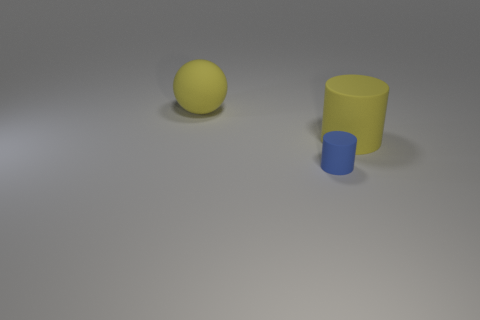What number of things are either big yellow objects that are in front of the big rubber ball or large yellow objects that are on the left side of the small blue cylinder?
Offer a very short reply. 2. There is a big matte thing in front of the ball; what color is it?
Make the answer very short. Yellow. There is a big rubber object that is to the right of the large yellow sphere; is there a rubber cylinder that is in front of it?
Your response must be concise. Yes. Is the number of big yellow balls less than the number of tiny cyan matte things?
Your answer should be compact. No. What material is the small blue object in front of the large yellow matte thing on the left side of the tiny blue matte cylinder?
Your response must be concise. Rubber. Do the rubber ball and the yellow rubber cylinder have the same size?
Keep it short and to the point. Yes. What number of objects are blue objects or yellow rubber objects?
Offer a terse response. 3. What is the size of the thing that is on the left side of the yellow cylinder and in front of the large sphere?
Your answer should be compact. Small. Are there fewer large rubber objects behind the tiny object than gray cylinders?
Give a very brief answer. No. There is a large object that is the same material as the yellow cylinder; what shape is it?
Your response must be concise. Sphere. 